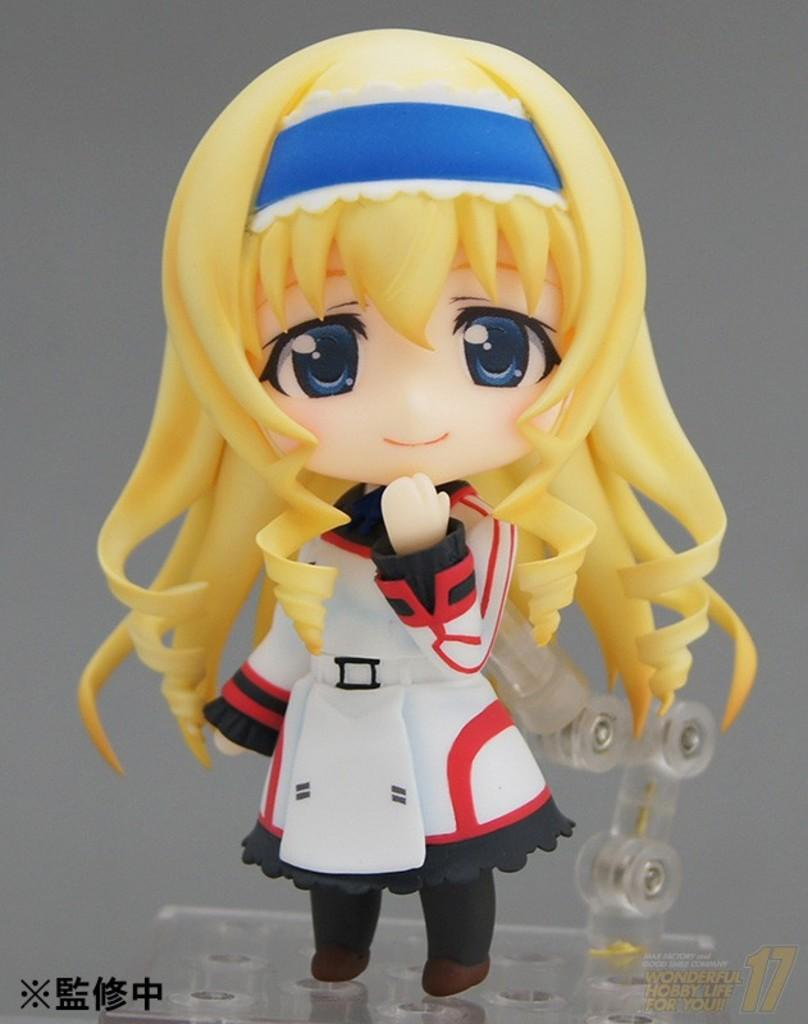What is the main subject of the image? There is a depiction of a girl in the center of the image. What else can be seen in the image besides the girl? There is text present in the image. What type of juice is being spilled on the girl in the image? There is no juice present in the image, and the girl is not depicted as being spilled on. 